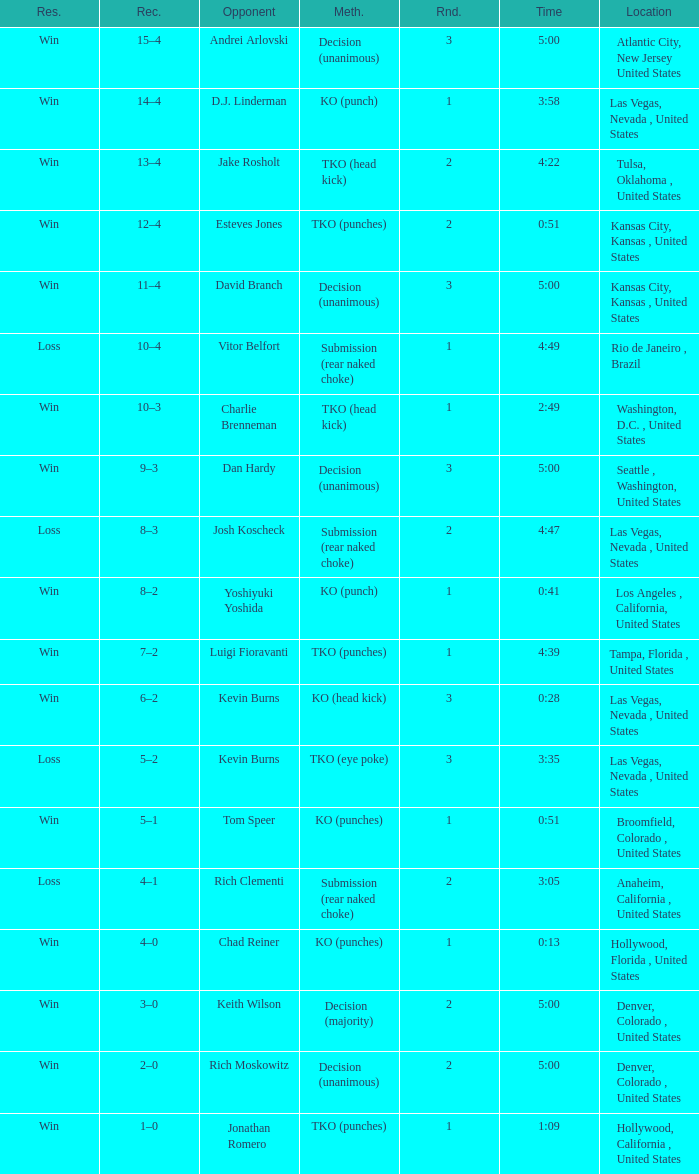What is the result for rounds under 2 against D.J. Linderman? Win. 